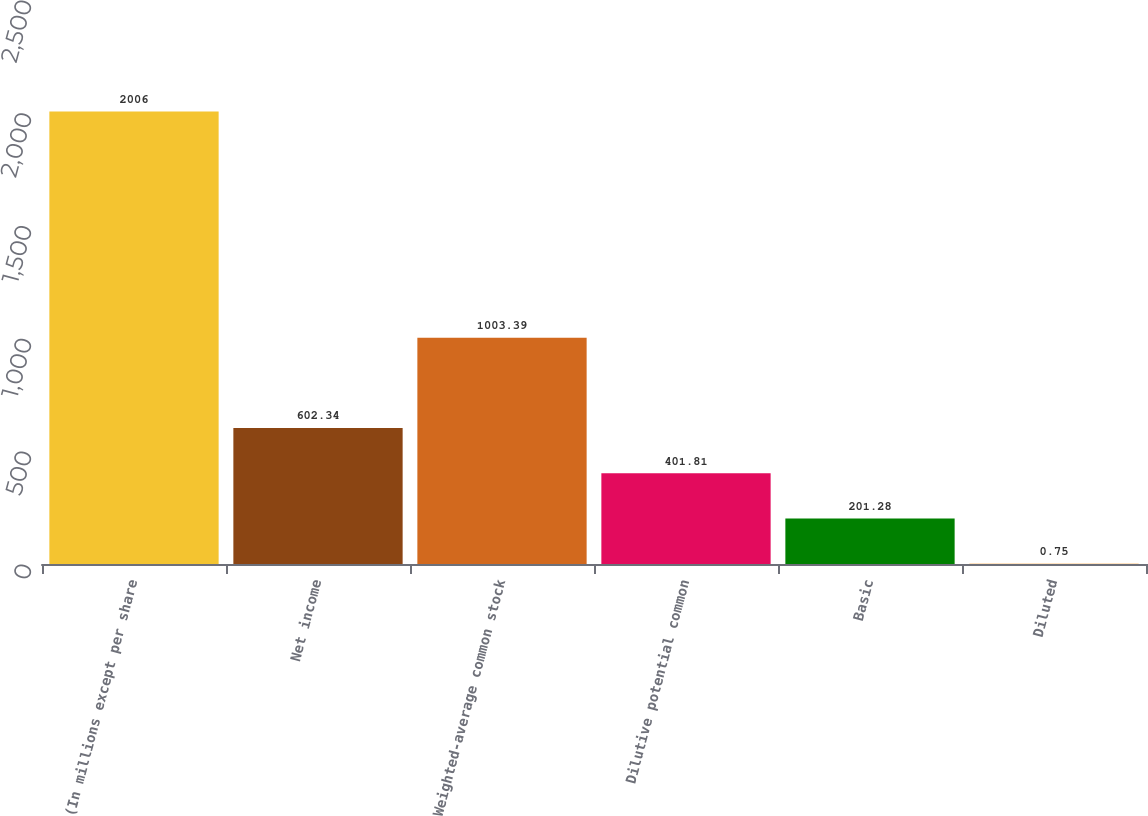<chart> <loc_0><loc_0><loc_500><loc_500><bar_chart><fcel>(In millions except per share<fcel>Net income<fcel>Weighted-average common stock<fcel>Dilutive potential common<fcel>Basic<fcel>Diluted<nl><fcel>2006<fcel>602.34<fcel>1003.39<fcel>401.81<fcel>201.28<fcel>0.75<nl></chart> 